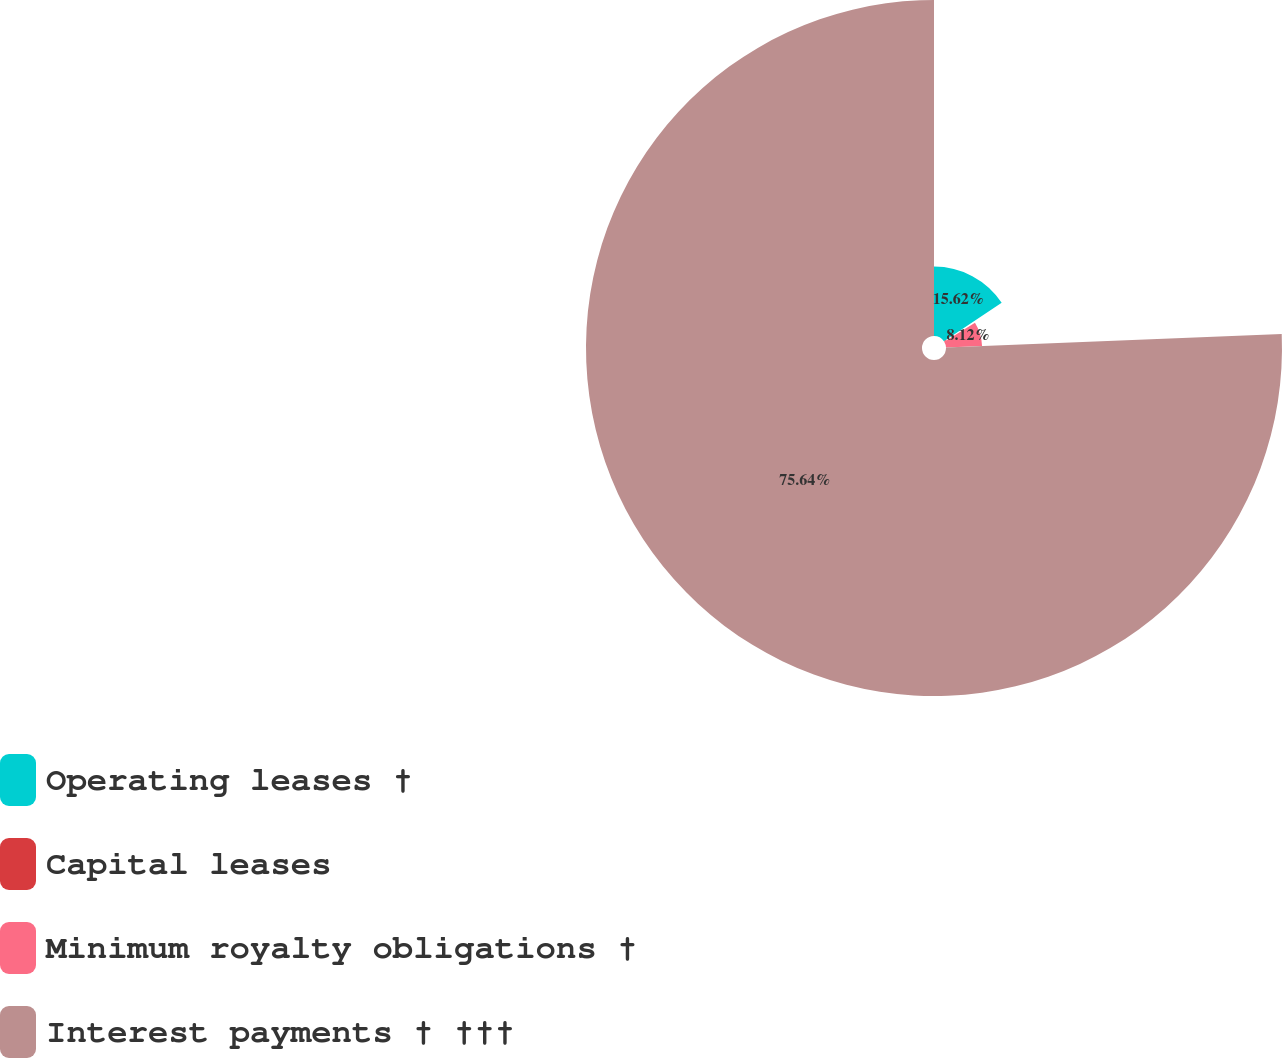<chart> <loc_0><loc_0><loc_500><loc_500><pie_chart><fcel>Operating leases †<fcel>Capital leases<fcel>Minimum royalty obligations †<fcel>Interest payments † †††<nl><fcel>15.62%<fcel>0.62%<fcel>8.12%<fcel>75.63%<nl></chart> 